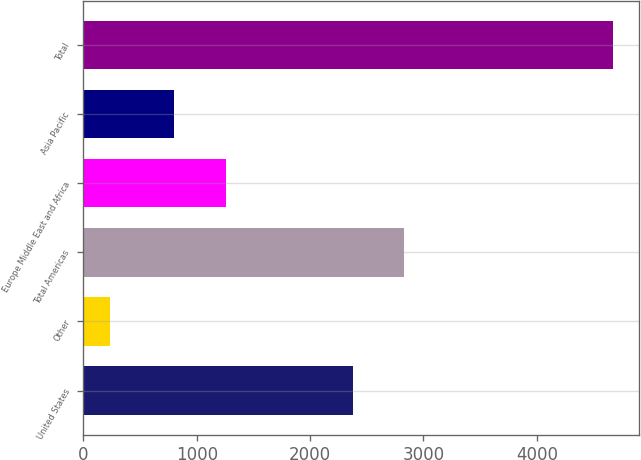Convert chart. <chart><loc_0><loc_0><loc_500><loc_500><bar_chart><fcel>United States<fcel>Other<fcel>Total Americas<fcel>Europe Middle East and Africa<fcel>Asia Pacific<fcel>Total<nl><fcel>2381.5<fcel>232<fcel>2825.21<fcel>1256.9<fcel>798.7<fcel>4669.1<nl></chart> 